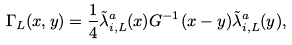Convert formula to latex. <formula><loc_0><loc_0><loc_500><loc_500>\Gamma _ { L } ( x , y ) = \frac { 1 } { 4 } \tilde { \lambda } _ { i , L } ^ { a } ( x ) G ^ { - 1 } ( x - y ) \tilde { \lambda } _ { i , L } ^ { a } ( y ) ,</formula> 